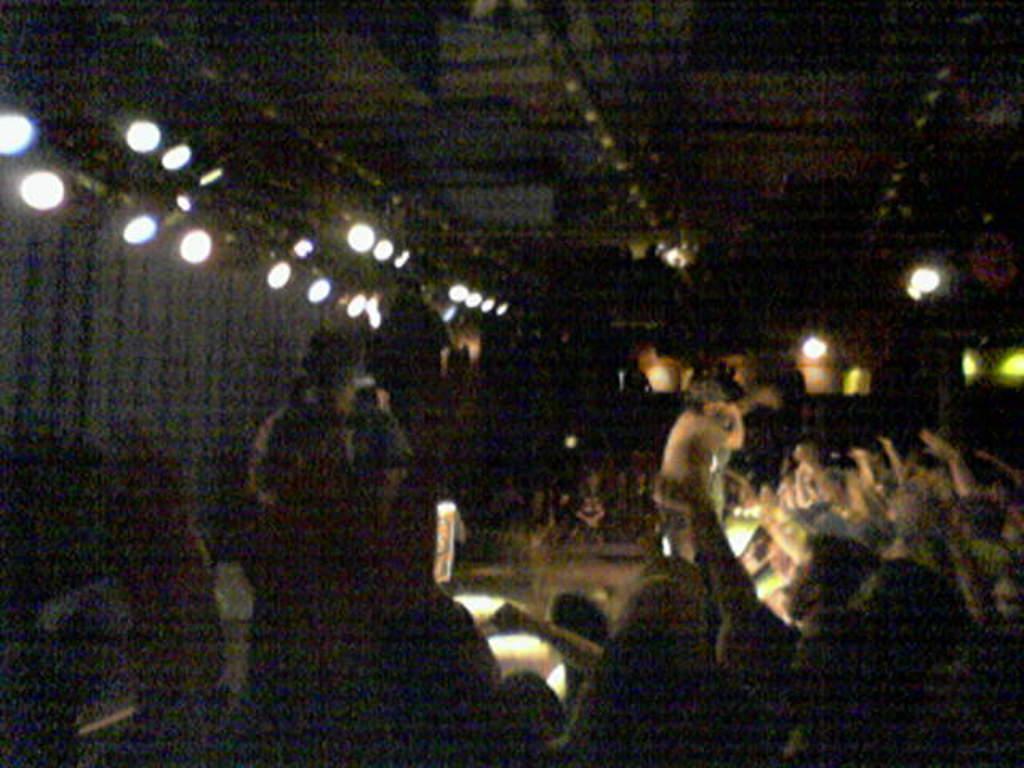In one or two sentences, can you explain what this image depicts? In this image we can see crowd sitting. In the center there is a person standing. At the top there are lights. In the background there is a wall. 